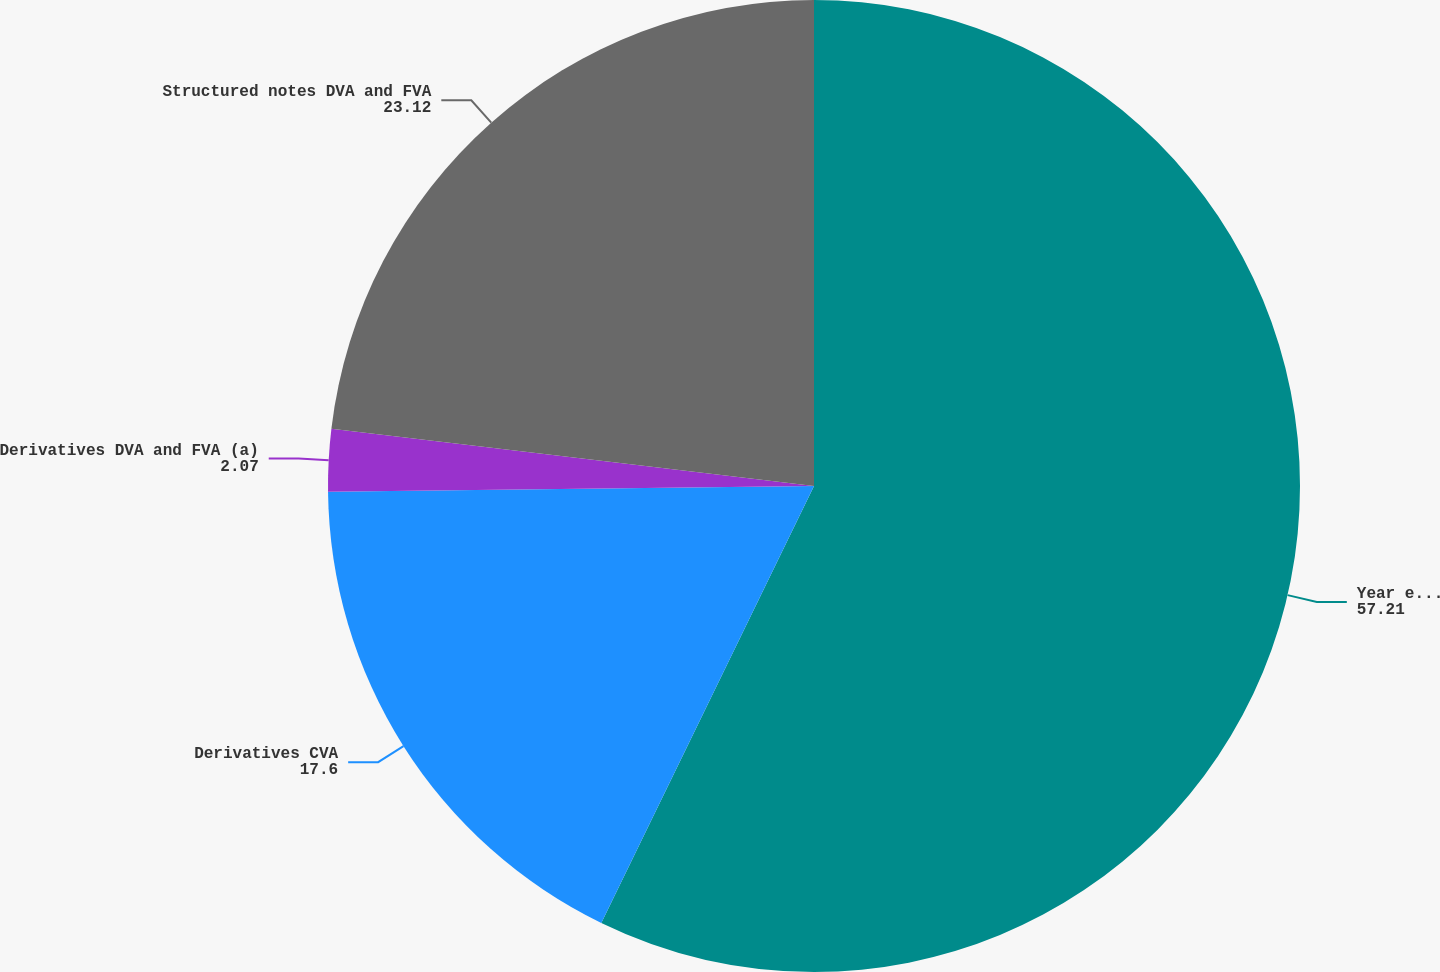Convert chart. <chart><loc_0><loc_0><loc_500><loc_500><pie_chart><fcel>Year ended December 31 (in<fcel>Derivatives CVA<fcel>Derivatives DVA and FVA (a)<fcel>Structured notes DVA and FVA<nl><fcel>57.21%<fcel>17.6%<fcel>2.07%<fcel>23.12%<nl></chart> 